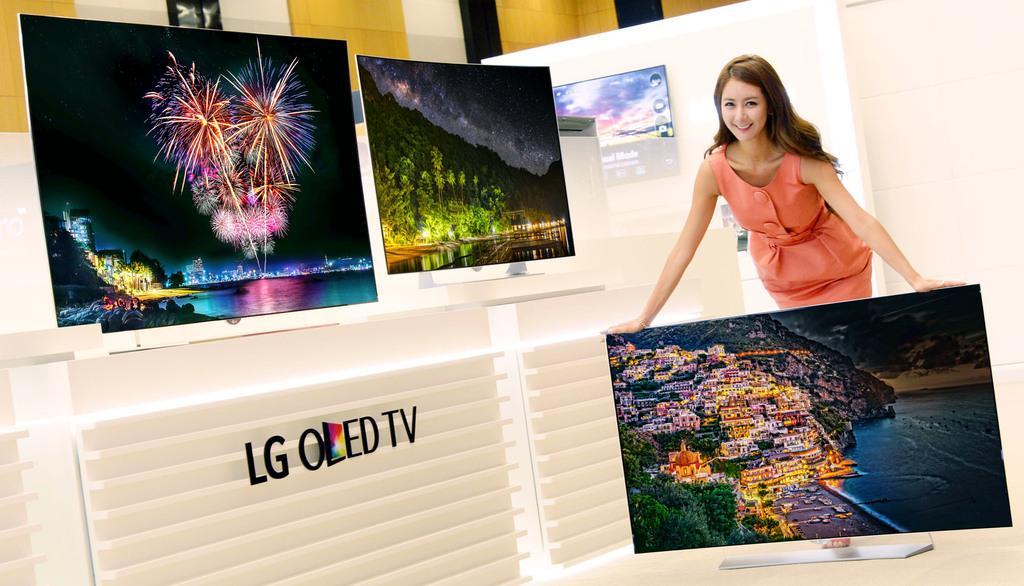Please provide a concise description of this image. In this image we can see there are two monitors placed on the table. On the right side of the image there is a girl holding another monitor which is placed on the floor. In the background there is a wall. 